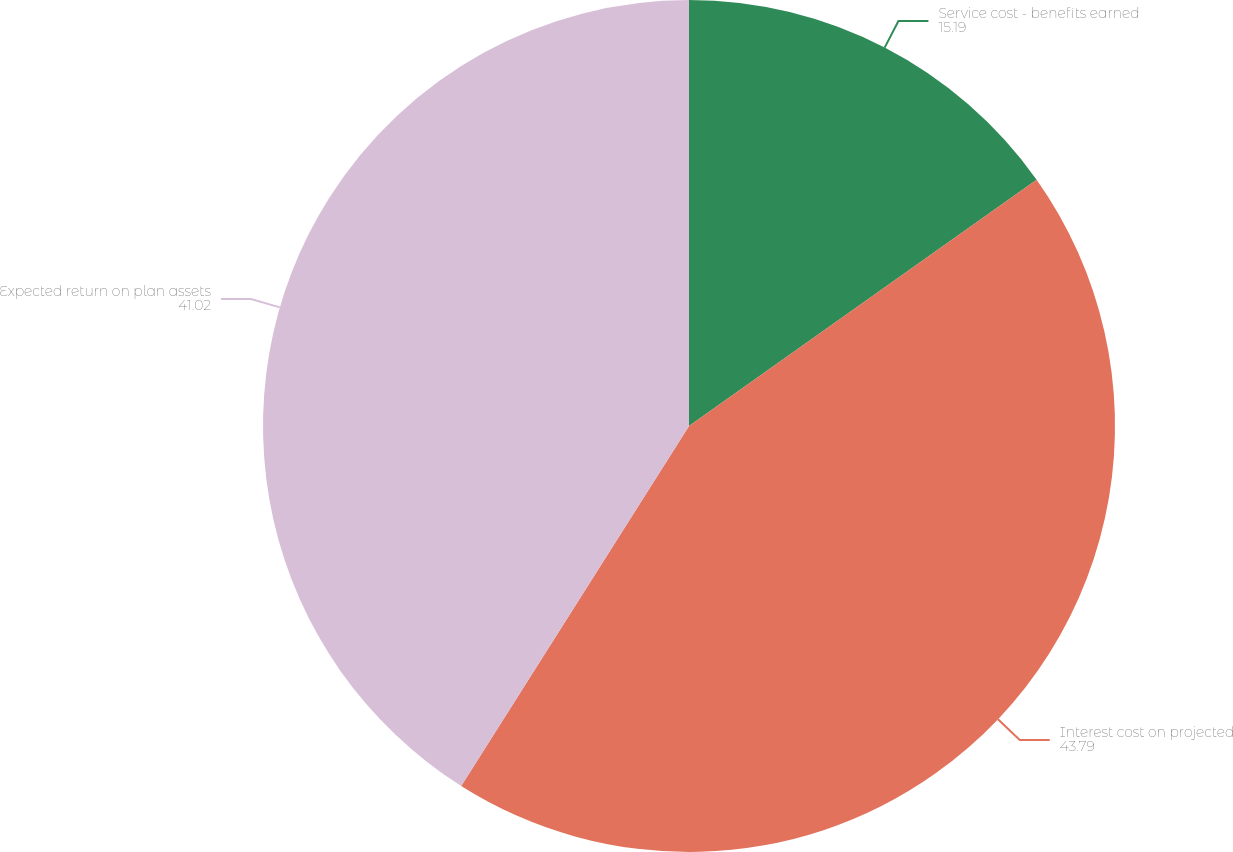Convert chart to OTSL. <chart><loc_0><loc_0><loc_500><loc_500><pie_chart><fcel>Service cost - benefits earned<fcel>Interest cost on projected<fcel>Expected return on plan assets<nl><fcel>15.19%<fcel>43.79%<fcel>41.02%<nl></chart> 